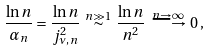Convert formula to latex. <formula><loc_0><loc_0><loc_500><loc_500>\frac { \ln n } { \alpha _ { n } } = \frac { \ln n } { j _ { \nu , \, n } ^ { 2 } } \, \overset { n \gg 1 } { \sim } \, \frac { \ln n } { n ^ { 2 } } \, \overset { n \to \infty } { \longrightarrow } \, 0 \, ,</formula> 